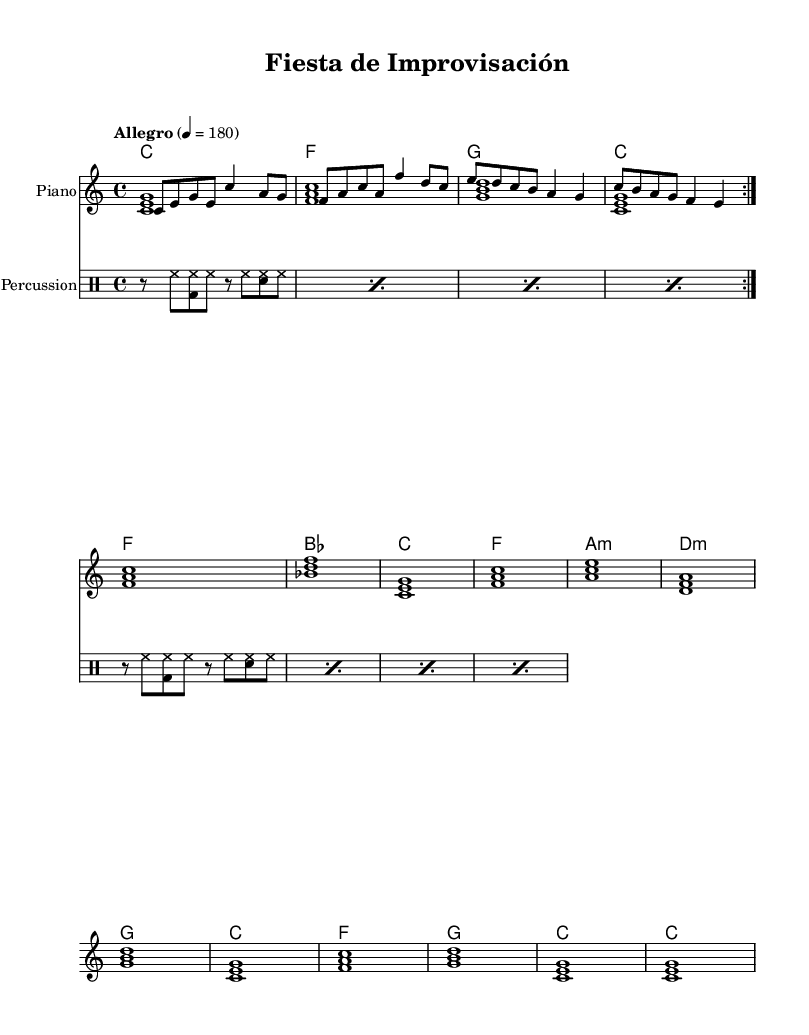What is the key signature of this music? The key signature is indicated at the beginning of the sheet music. In this case, C major is used, which has no sharps or flats.
Answer: C major What is the time signature of this music? The time signature is located at the beginning as well. Here, it is 4/4, indicating that there are four beats in each measure and a quarter note receives one beat.
Answer: 4/4 What is the tempo marking of this piece? The tempo marking is found at the beginning. It specifies "Allegro," suggesting a fast and lively pace, with a metronome marking of 180 beats per minute.
Answer: Allegro How many measures are in the melody? To determine the number of measures, we can count each measure in the melody section. In this piece, the melody is repeated twice, and each repeat contains four measures, giving a total of eight measures.
Answer: 8 What is the final chord in the harmonies? The final chord can be found at the end of the chord progression. In this sheet music, the last chord displayed is C major, which consists of the notes C, E, and G.
Answer: C What type of percussion instrument is indicated? In the percussion section, the notation shows specific drum sounds indicating the use of a hi-hat, bass drum, and snare drum. These are standard percussion instruments used in merengue music to provide a strong rhythmic foundation.
Answer: Hi-hat, bass drum, and snare drum What is the primary mood conveyed by this piece? By analyzing the tempo, lively melody, and upbeat rhythm, the overall mood of the piece can be identified as festive and energetic, typical for merengue music, which is designed to engage the audience in high-energy interactions.
Answer: Festive and energetic 